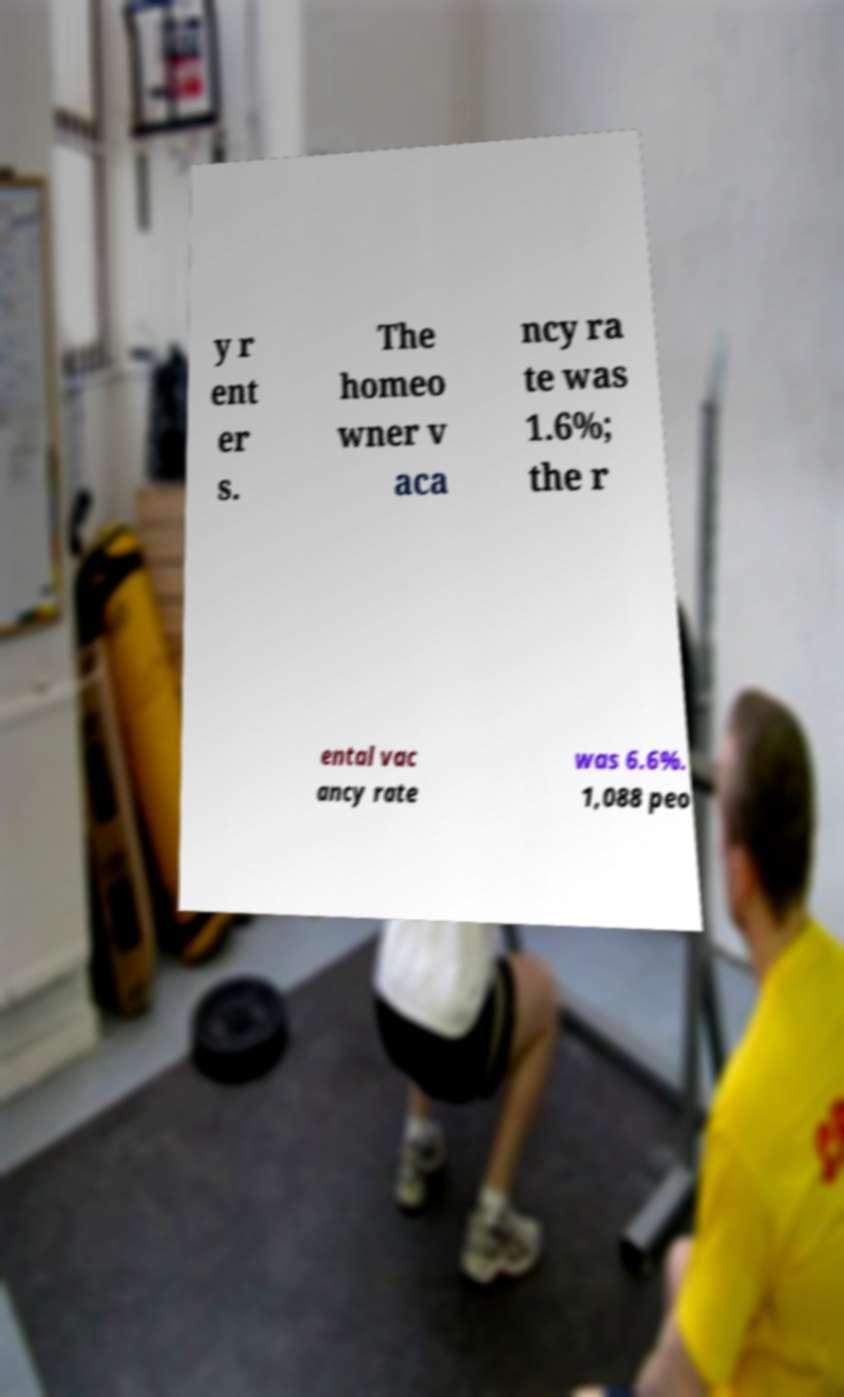What messages or text are displayed in this image? I need them in a readable, typed format. y r ent er s. The homeo wner v aca ncy ra te was 1.6%; the r ental vac ancy rate was 6.6%. 1,088 peo 